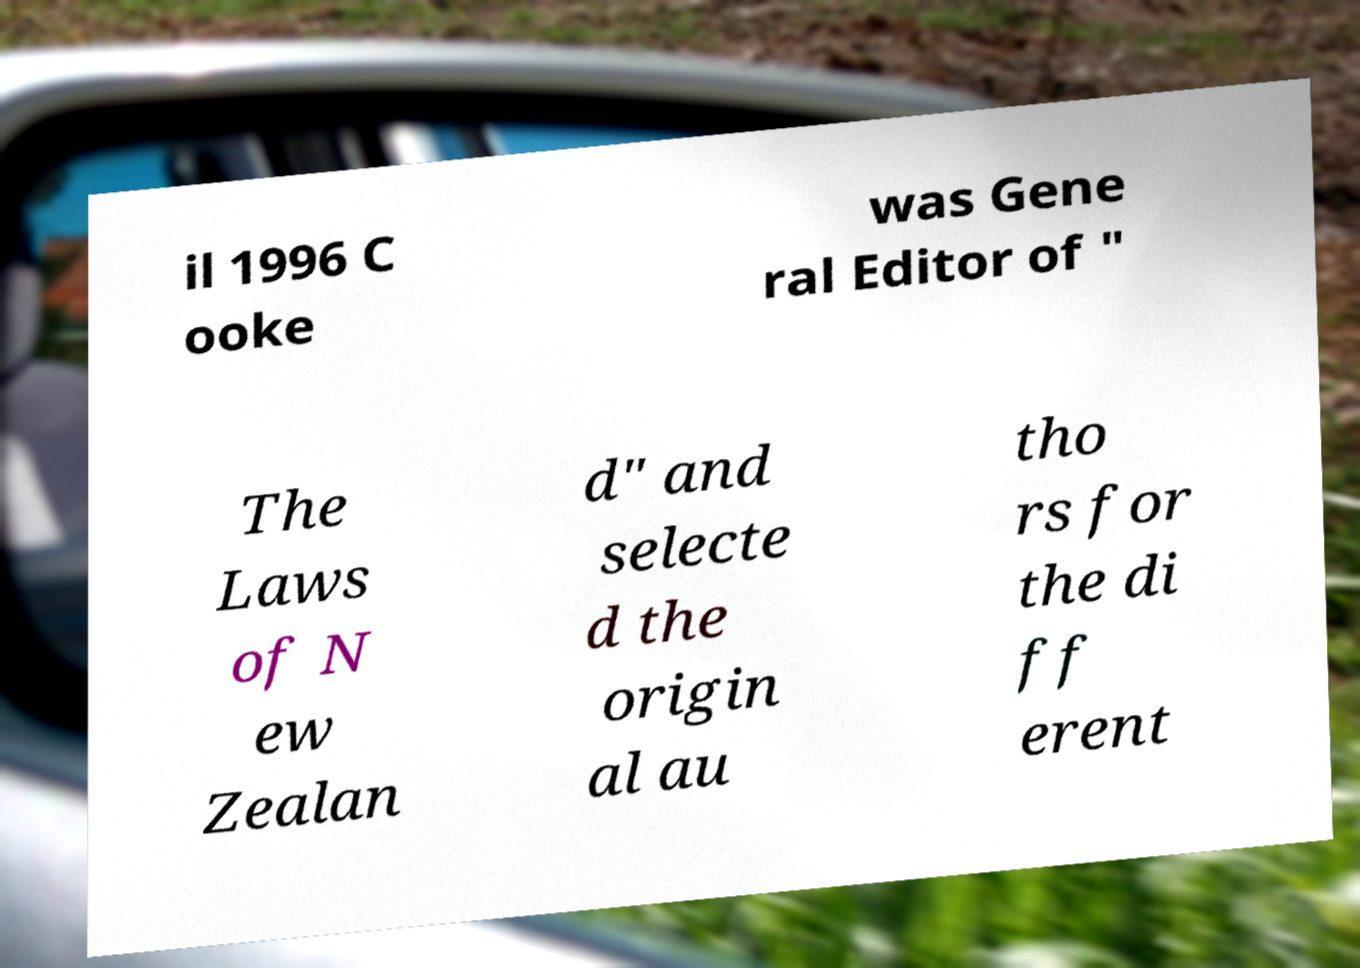For documentation purposes, I need the text within this image transcribed. Could you provide that? il 1996 C ooke was Gene ral Editor of " The Laws of N ew Zealan d" and selecte d the origin al au tho rs for the di ff erent 